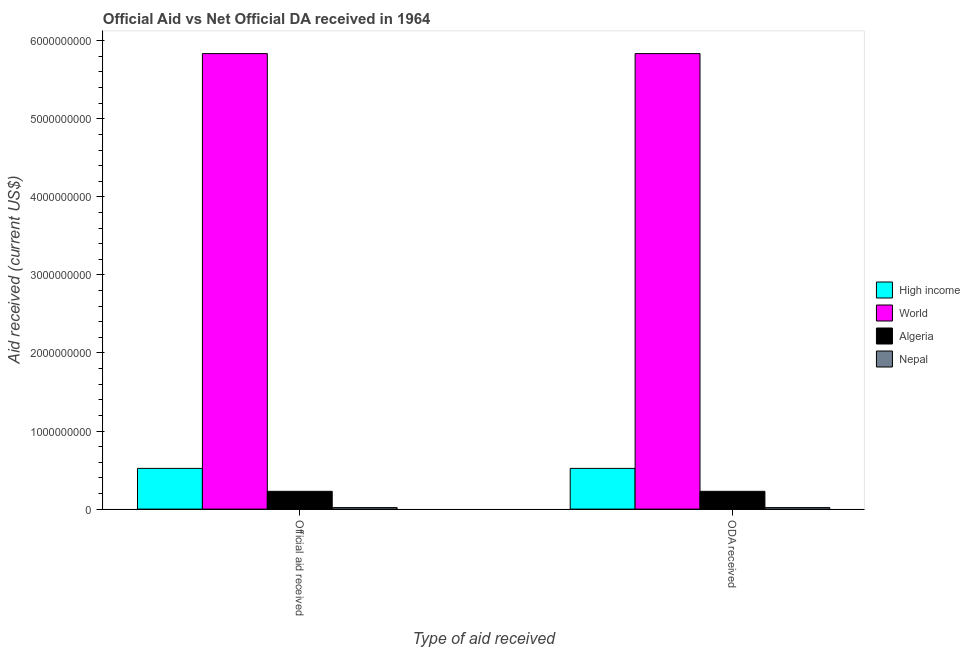How many groups of bars are there?
Provide a short and direct response. 2. Are the number of bars per tick equal to the number of legend labels?
Make the answer very short. Yes. Are the number of bars on each tick of the X-axis equal?
Keep it short and to the point. Yes. How many bars are there on the 1st tick from the left?
Your answer should be compact. 4. How many bars are there on the 1st tick from the right?
Your response must be concise. 4. What is the label of the 1st group of bars from the left?
Your answer should be very brief. Official aid received. What is the oda received in High income?
Your response must be concise. 5.22e+08. Across all countries, what is the maximum official aid received?
Your response must be concise. 5.84e+09. Across all countries, what is the minimum official aid received?
Provide a succinct answer. 1.95e+07. In which country was the official aid received maximum?
Your answer should be compact. World. In which country was the official aid received minimum?
Keep it short and to the point. Nepal. What is the total oda received in the graph?
Offer a terse response. 6.60e+09. What is the difference between the official aid received in Nepal and that in Algeria?
Your answer should be very brief. -2.08e+08. What is the difference between the oda received in Algeria and the official aid received in World?
Provide a short and direct response. -5.61e+09. What is the average official aid received per country?
Your response must be concise. 1.65e+09. What is the ratio of the oda received in Nepal to that in World?
Ensure brevity in your answer.  0. Is the oda received in Nepal less than that in World?
Give a very brief answer. Yes. How many bars are there?
Your response must be concise. 8. Are all the bars in the graph horizontal?
Make the answer very short. No. How many countries are there in the graph?
Provide a succinct answer. 4. What is the difference between two consecutive major ticks on the Y-axis?
Keep it short and to the point. 1.00e+09. Does the graph contain grids?
Your answer should be compact. No. Where does the legend appear in the graph?
Provide a succinct answer. Center right. How many legend labels are there?
Provide a succinct answer. 4. What is the title of the graph?
Your answer should be very brief. Official Aid vs Net Official DA received in 1964 . What is the label or title of the X-axis?
Your answer should be very brief. Type of aid received. What is the label or title of the Y-axis?
Provide a short and direct response. Aid received (current US$). What is the Aid received (current US$) in High income in Official aid received?
Your answer should be compact. 5.22e+08. What is the Aid received (current US$) in World in Official aid received?
Make the answer very short. 5.84e+09. What is the Aid received (current US$) of Algeria in Official aid received?
Your response must be concise. 2.28e+08. What is the Aid received (current US$) in Nepal in Official aid received?
Provide a succinct answer. 1.95e+07. What is the Aid received (current US$) in High income in ODA received?
Offer a terse response. 5.22e+08. What is the Aid received (current US$) of World in ODA received?
Give a very brief answer. 5.84e+09. What is the Aid received (current US$) of Algeria in ODA received?
Your answer should be compact. 2.28e+08. What is the Aid received (current US$) of Nepal in ODA received?
Keep it short and to the point. 1.95e+07. Across all Type of aid received, what is the maximum Aid received (current US$) in High income?
Make the answer very short. 5.22e+08. Across all Type of aid received, what is the maximum Aid received (current US$) of World?
Provide a succinct answer. 5.84e+09. Across all Type of aid received, what is the maximum Aid received (current US$) of Algeria?
Keep it short and to the point. 2.28e+08. Across all Type of aid received, what is the maximum Aid received (current US$) in Nepal?
Keep it short and to the point. 1.95e+07. Across all Type of aid received, what is the minimum Aid received (current US$) in High income?
Offer a very short reply. 5.22e+08. Across all Type of aid received, what is the minimum Aid received (current US$) in World?
Your response must be concise. 5.84e+09. Across all Type of aid received, what is the minimum Aid received (current US$) of Algeria?
Keep it short and to the point. 2.28e+08. Across all Type of aid received, what is the minimum Aid received (current US$) in Nepal?
Make the answer very short. 1.95e+07. What is the total Aid received (current US$) of High income in the graph?
Provide a succinct answer. 1.04e+09. What is the total Aid received (current US$) of World in the graph?
Provide a short and direct response. 1.17e+1. What is the total Aid received (current US$) of Algeria in the graph?
Your response must be concise. 4.56e+08. What is the total Aid received (current US$) in Nepal in the graph?
Offer a terse response. 3.90e+07. What is the difference between the Aid received (current US$) of World in Official aid received and that in ODA received?
Your answer should be compact. 0. What is the difference between the Aid received (current US$) of Algeria in Official aid received and that in ODA received?
Make the answer very short. 0. What is the difference between the Aid received (current US$) of Nepal in Official aid received and that in ODA received?
Keep it short and to the point. 0. What is the difference between the Aid received (current US$) in High income in Official aid received and the Aid received (current US$) in World in ODA received?
Offer a very short reply. -5.31e+09. What is the difference between the Aid received (current US$) of High income in Official aid received and the Aid received (current US$) of Algeria in ODA received?
Make the answer very short. 2.94e+08. What is the difference between the Aid received (current US$) in High income in Official aid received and the Aid received (current US$) in Nepal in ODA received?
Offer a very short reply. 5.02e+08. What is the difference between the Aid received (current US$) of World in Official aid received and the Aid received (current US$) of Algeria in ODA received?
Keep it short and to the point. 5.61e+09. What is the difference between the Aid received (current US$) of World in Official aid received and the Aid received (current US$) of Nepal in ODA received?
Your answer should be compact. 5.82e+09. What is the difference between the Aid received (current US$) of Algeria in Official aid received and the Aid received (current US$) of Nepal in ODA received?
Provide a short and direct response. 2.08e+08. What is the average Aid received (current US$) of High income per Type of aid received?
Give a very brief answer. 5.22e+08. What is the average Aid received (current US$) of World per Type of aid received?
Your response must be concise. 5.84e+09. What is the average Aid received (current US$) in Algeria per Type of aid received?
Provide a succinct answer. 2.28e+08. What is the average Aid received (current US$) of Nepal per Type of aid received?
Give a very brief answer. 1.95e+07. What is the difference between the Aid received (current US$) in High income and Aid received (current US$) in World in Official aid received?
Ensure brevity in your answer.  -5.31e+09. What is the difference between the Aid received (current US$) of High income and Aid received (current US$) of Algeria in Official aid received?
Your answer should be very brief. 2.94e+08. What is the difference between the Aid received (current US$) of High income and Aid received (current US$) of Nepal in Official aid received?
Offer a terse response. 5.02e+08. What is the difference between the Aid received (current US$) of World and Aid received (current US$) of Algeria in Official aid received?
Ensure brevity in your answer.  5.61e+09. What is the difference between the Aid received (current US$) of World and Aid received (current US$) of Nepal in Official aid received?
Your answer should be compact. 5.82e+09. What is the difference between the Aid received (current US$) of Algeria and Aid received (current US$) of Nepal in Official aid received?
Ensure brevity in your answer.  2.08e+08. What is the difference between the Aid received (current US$) in High income and Aid received (current US$) in World in ODA received?
Make the answer very short. -5.31e+09. What is the difference between the Aid received (current US$) of High income and Aid received (current US$) of Algeria in ODA received?
Your answer should be compact. 2.94e+08. What is the difference between the Aid received (current US$) of High income and Aid received (current US$) of Nepal in ODA received?
Give a very brief answer. 5.02e+08. What is the difference between the Aid received (current US$) in World and Aid received (current US$) in Algeria in ODA received?
Offer a very short reply. 5.61e+09. What is the difference between the Aid received (current US$) in World and Aid received (current US$) in Nepal in ODA received?
Your answer should be very brief. 5.82e+09. What is the difference between the Aid received (current US$) of Algeria and Aid received (current US$) of Nepal in ODA received?
Ensure brevity in your answer.  2.08e+08. What is the difference between the highest and the second highest Aid received (current US$) of World?
Keep it short and to the point. 0. What is the difference between the highest and the second highest Aid received (current US$) of Algeria?
Give a very brief answer. 0. What is the difference between the highest and the lowest Aid received (current US$) of World?
Offer a terse response. 0. 